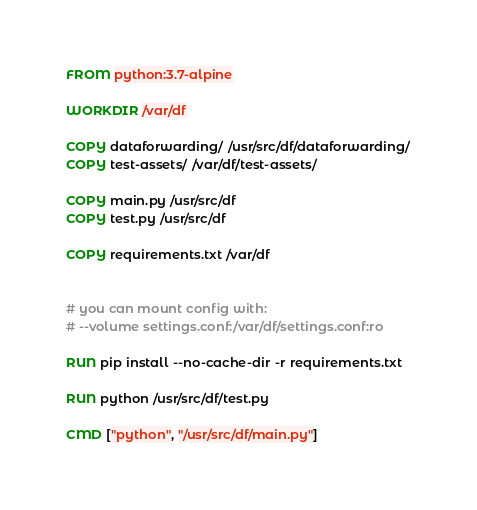Convert code to text. <code><loc_0><loc_0><loc_500><loc_500><_Dockerfile_>FROM python:3.7-alpine

WORKDIR /var/df

COPY dataforwarding/ /usr/src/df/dataforwarding/
COPY test-assets/ /var/df/test-assets/

COPY main.py /usr/src/df
COPY test.py /usr/src/df

COPY requirements.txt /var/df


# you can mount config with:
# --volume settings.conf:/var/df/settings.conf:ro

RUN pip install --no-cache-dir -r requirements.txt

RUN python /usr/src/df/test.py

CMD ["python", "/usr/src/df/main.py"]</code> 